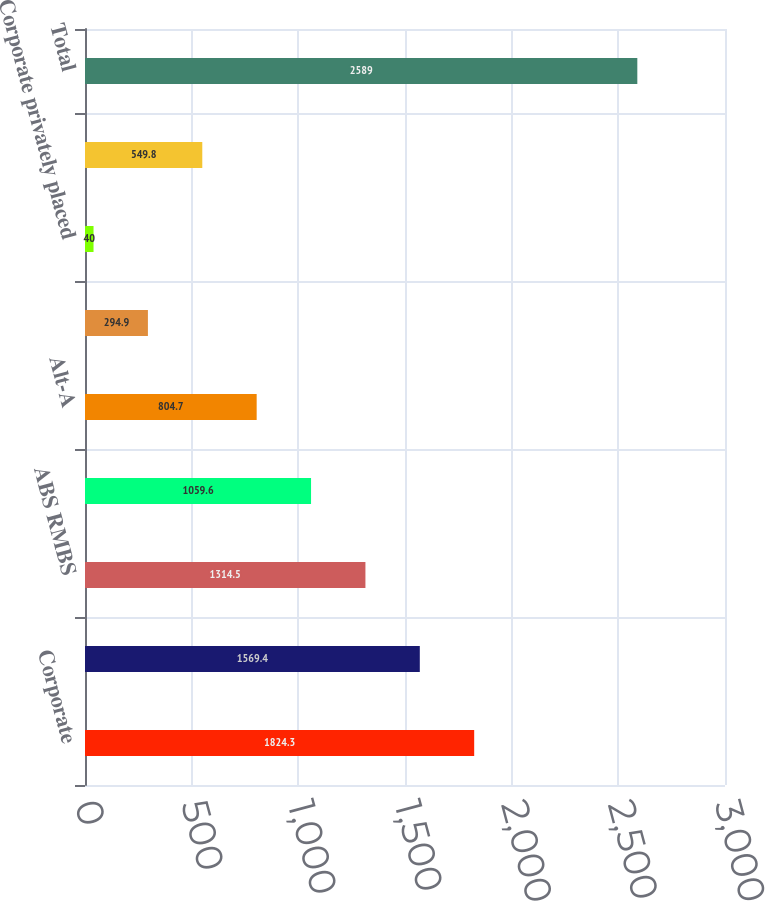Convert chart. <chart><loc_0><loc_0><loc_500><loc_500><bar_chart><fcel>Corporate<fcel>Finance sector (1)<fcel>ABS RMBS<fcel>Municipal<fcel>Alt-A<fcel>Prime<fcel>Corporate privately placed<fcel>Other<fcel>Total<nl><fcel>1824.3<fcel>1569.4<fcel>1314.5<fcel>1059.6<fcel>804.7<fcel>294.9<fcel>40<fcel>549.8<fcel>2589<nl></chart> 